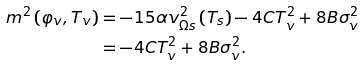<formula> <loc_0><loc_0><loc_500><loc_500>m ^ { 2 } \left ( \varphi _ { v } , T _ { v } \right ) & = - 1 5 \alpha v _ { \Omega s } ^ { 2 } \left ( T _ { s } \right ) - 4 C T _ { v } ^ { 2 } + 8 B \sigma _ { v } ^ { 2 } \\ & = - 4 C T _ { v } ^ { 2 } + 8 B \sigma _ { v } ^ { 2 } \text {.}</formula> 